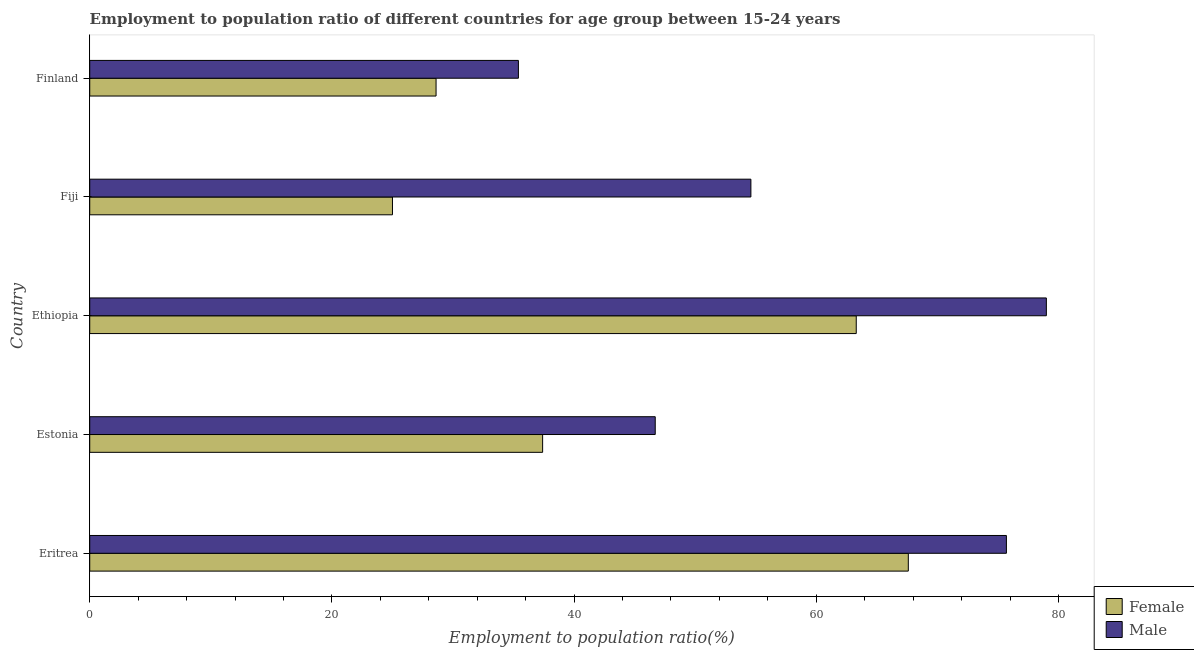How many different coloured bars are there?
Give a very brief answer. 2. How many groups of bars are there?
Your answer should be very brief. 5. How many bars are there on the 4th tick from the top?
Ensure brevity in your answer.  2. What is the label of the 5th group of bars from the top?
Make the answer very short. Eritrea. In how many cases, is the number of bars for a given country not equal to the number of legend labels?
Provide a succinct answer. 0. What is the employment to population ratio(male) in Fiji?
Offer a terse response. 54.6. Across all countries, what is the maximum employment to population ratio(male)?
Give a very brief answer. 79. Across all countries, what is the minimum employment to population ratio(male)?
Offer a very short reply. 35.4. In which country was the employment to population ratio(male) maximum?
Give a very brief answer. Ethiopia. In which country was the employment to population ratio(male) minimum?
Your response must be concise. Finland. What is the total employment to population ratio(male) in the graph?
Offer a terse response. 291.4. What is the difference between the employment to population ratio(female) in Eritrea and the employment to population ratio(male) in Fiji?
Offer a terse response. 13. What is the average employment to population ratio(male) per country?
Offer a very short reply. 58.28. What is the difference between the employment to population ratio(female) and employment to population ratio(male) in Finland?
Your response must be concise. -6.8. In how many countries, is the employment to population ratio(male) greater than 32 %?
Offer a very short reply. 5. What is the ratio of the employment to population ratio(male) in Estonia to that in Fiji?
Keep it short and to the point. 0.85. What is the difference between the highest and the lowest employment to population ratio(female)?
Provide a succinct answer. 42.6. In how many countries, is the employment to population ratio(female) greater than the average employment to population ratio(female) taken over all countries?
Offer a terse response. 2. Is the sum of the employment to population ratio(male) in Eritrea and Finland greater than the maximum employment to population ratio(female) across all countries?
Give a very brief answer. Yes. What does the 1st bar from the bottom in Fiji represents?
Provide a short and direct response. Female. How many bars are there?
Provide a short and direct response. 10. Are all the bars in the graph horizontal?
Make the answer very short. Yes. Does the graph contain grids?
Your answer should be compact. No. How many legend labels are there?
Provide a short and direct response. 2. What is the title of the graph?
Give a very brief answer. Employment to population ratio of different countries for age group between 15-24 years. Does "Electricity" appear as one of the legend labels in the graph?
Offer a very short reply. No. What is the label or title of the Y-axis?
Your answer should be very brief. Country. What is the Employment to population ratio(%) of Female in Eritrea?
Offer a terse response. 67.6. What is the Employment to population ratio(%) of Male in Eritrea?
Make the answer very short. 75.7. What is the Employment to population ratio(%) in Female in Estonia?
Offer a very short reply. 37.4. What is the Employment to population ratio(%) in Male in Estonia?
Ensure brevity in your answer.  46.7. What is the Employment to population ratio(%) in Female in Ethiopia?
Provide a succinct answer. 63.3. What is the Employment to population ratio(%) in Male in Ethiopia?
Your response must be concise. 79. What is the Employment to population ratio(%) in Male in Fiji?
Your answer should be very brief. 54.6. What is the Employment to population ratio(%) in Female in Finland?
Your response must be concise. 28.6. What is the Employment to population ratio(%) in Male in Finland?
Your answer should be very brief. 35.4. Across all countries, what is the maximum Employment to population ratio(%) of Female?
Provide a short and direct response. 67.6. Across all countries, what is the maximum Employment to population ratio(%) of Male?
Your answer should be very brief. 79. Across all countries, what is the minimum Employment to population ratio(%) of Female?
Your answer should be very brief. 25. Across all countries, what is the minimum Employment to population ratio(%) in Male?
Keep it short and to the point. 35.4. What is the total Employment to population ratio(%) of Female in the graph?
Offer a very short reply. 221.9. What is the total Employment to population ratio(%) in Male in the graph?
Offer a very short reply. 291.4. What is the difference between the Employment to population ratio(%) in Female in Eritrea and that in Estonia?
Your answer should be compact. 30.2. What is the difference between the Employment to population ratio(%) of Male in Eritrea and that in Estonia?
Your response must be concise. 29. What is the difference between the Employment to population ratio(%) in Female in Eritrea and that in Fiji?
Offer a very short reply. 42.6. What is the difference between the Employment to population ratio(%) of Male in Eritrea and that in Fiji?
Provide a short and direct response. 21.1. What is the difference between the Employment to population ratio(%) of Male in Eritrea and that in Finland?
Make the answer very short. 40.3. What is the difference between the Employment to population ratio(%) of Female in Estonia and that in Ethiopia?
Give a very brief answer. -25.9. What is the difference between the Employment to population ratio(%) in Male in Estonia and that in Ethiopia?
Your answer should be compact. -32.3. What is the difference between the Employment to population ratio(%) of Female in Estonia and that in Fiji?
Offer a terse response. 12.4. What is the difference between the Employment to population ratio(%) in Male in Estonia and that in Finland?
Provide a succinct answer. 11.3. What is the difference between the Employment to population ratio(%) in Female in Ethiopia and that in Fiji?
Offer a terse response. 38.3. What is the difference between the Employment to population ratio(%) in Male in Ethiopia and that in Fiji?
Your answer should be very brief. 24.4. What is the difference between the Employment to population ratio(%) in Female in Ethiopia and that in Finland?
Your response must be concise. 34.7. What is the difference between the Employment to population ratio(%) of Male in Ethiopia and that in Finland?
Make the answer very short. 43.6. What is the difference between the Employment to population ratio(%) of Female in Fiji and that in Finland?
Provide a succinct answer. -3.6. What is the difference between the Employment to population ratio(%) in Male in Fiji and that in Finland?
Your answer should be compact. 19.2. What is the difference between the Employment to population ratio(%) of Female in Eritrea and the Employment to population ratio(%) of Male in Estonia?
Keep it short and to the point. 20.9. What is the difference between the Employment to population ratio(%) of Female in Eritrea and the Employment to population ratio(%) of Male in Ethiopia?
Offer a terse response. -11.4. What is the difference between the Employment to population ratio(%) in Female in Eritrea and the Employment to population ratio(%) in Male in Finland?
Make the answer very short. 32.2. What is the difference between the Employment to population ratio(%) of Female in Estonia and the Employment to population ratio(%) of Male in Ethiopia?
Offer a terse response. -41.6. What is the difference between the Employment to population ratio(%) of Female in Estonia and the Employment to population ratio(%) of Male in Fiji?
Ensure brevity in your answer.  -17.2. What is the difference between the Employment to population ratio(%) of Female in Ethiopia and the Employment to population ratio(%) of Male in Fiji?
Keep it short and to the point. 8.7. What is the difference between the Employment to population ratio(%) in Female in Ethiopia and the Employment to population ratio(%) in Male in Finland?
Give a very brief answer. 27.9. What is the average Employment to population ratio(%) of Female per country?
Keep it short and to the point. 44.38. What is the average Employment to population ratio(%) of Male per country?
Provide a short and direct response. 58.28. What is the difference between the Employment to population ratio(%) in Female and Employment to population ratio(%) in Male in Ethiopia?
Offer a very short reply. -15.7. What is the difference between the Employment to population ratio(%) in Female and Employment to population ratio(%) in Male in Fiji?
Provide a short and direct response. -29.6. What is the difference between the Employment to population ratio(%) of Female and Employment to population ratio(%) of Male in Finland?
Your answer should be compact. -6.8. What is the ratio of the Employment to population ratio(%) in Female in Eritrea to that in Estonia?
Your answer should be compact. 1.81. What is the ratio of the Employment to population ratio(%) of Male in Eritrea to that in Estonia?
Make the answer very short. 1.62. What is the ratio of the Employment to population ratio(%) in Female in Eritrea to that in Ethiopia?
Your answer should be compact. 1.07. What is the ratio of the Employment to population ratio(%) in Male in Eritrea to that in Ethiopia?
Give a very brief answer. 0.96. What is the ratio of the Employment to population ratio(%) of Female in Eritrea to that in Fiji?
Keep it short and to the point. 2.7. What is the ratio of the Employment to population ratio(%) in Male in Eritrea to that in Fiji?
Provide a succinct answer. 1.39. What is the ratio of the Employment to population ratio(%) in Female in Eritrea to that in Finland?
Offer a very short reply. 2.36. What is the ratio of the Employment to population ratio(%) in Male in Eritrea to that in Finland?
Make the answer very short. 2.14. What is the ratio of the Employment to population ratio(%) in Female in Estonia to that in Ethiopia?
Your answer should be very brief. 0.59. What is the ratio of the Employment to population ratio(%) of Male in Estonia to that in Ethiopia?
Give a very brief answer. 0.59. What is the ratio of the Employment to population ratio(%) of Female in Estonia to that in Fiji?
Your answer should be compact. 1.5. What is the ratio of the Employment to population ratio(%) in Male in Estonia to that in Fiji?
Offer a terse response. 0.86. What is the ratio of the Employment to population ratio(%) in Female in Estonia to that in Finland?
Give a very brief answer. 1.31. What is the ratio of the Employment to population ratio(%) in Male in Estonia to that in Finland?
Ensure brevity in your answer.  1.32. What is the ratio of the Employment to population ratio(%) of Female in Ethiopia to that in Fiji?
Make the answer very short. 2.53. What is the ratio of the Employment to population ratio(%) of Male in Ethiopia to that in Fiji?
Give a very brief answer. 1.45. What is the ratio of the Employment to population ratio(%) of Female in Ethiopia to that in Finland?
Keep it short and to the point. 2.21. What is the ratio of the Employment to population ratio(%) of Male in Ethiopia to that in Finland?
Provide a short and direct response. 2.23. What is the ratio of the Employment to population ratio(%) in Female in Fiji to that in Finland?
Provide a short and direct response. 0.87. What is the ratio of the Employment to population ratio(%) in Male in Fiji to that in Finland?
Ensure brevity in your answer.  1.54. What is the difference between the highest and the lowest Employment to population ratio(%) in Female?
Provide a short and direct response. 42.6. What is the difference between the highest and the lowest Employment to population ratio(%) of Male?
Provide a short and direct response. 43.6. 